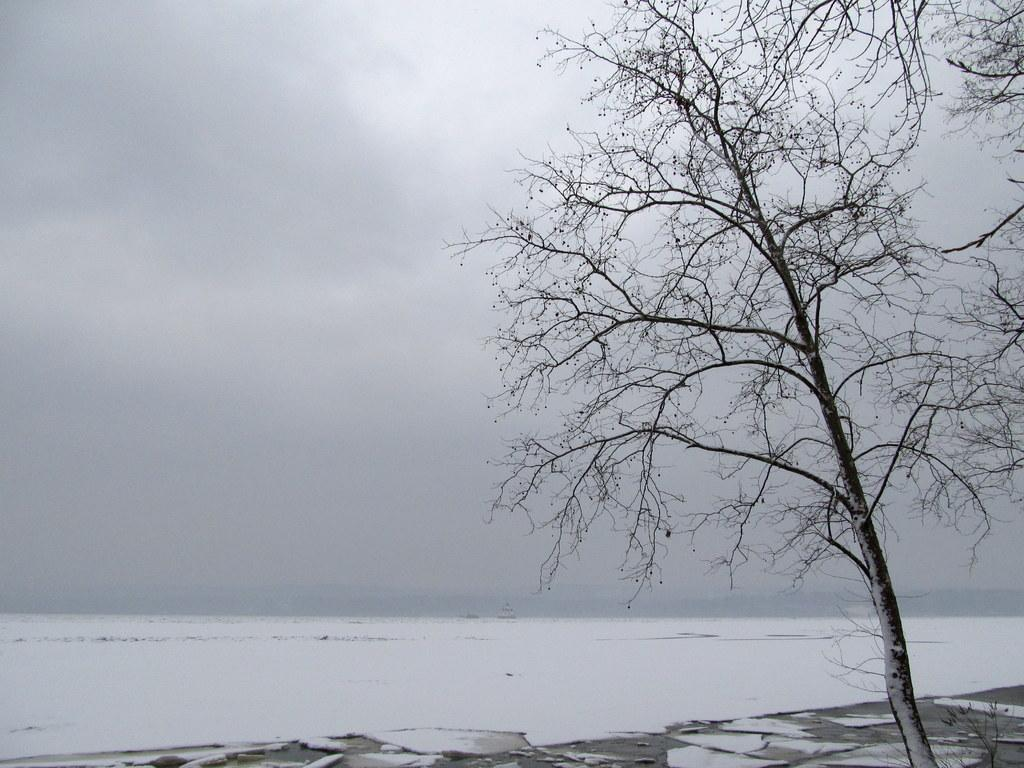What type of weather is depicted in the image? There is snow in the image, indicating cold weather. What natural element is present in the image? There is a tree in the image. What is visible in the sky in the image? Clouds are visible in the sky. What type of harmony can be heard in the image? There is no sound or music present in the image, so it is not possible to determine if any harmony can be heard. 